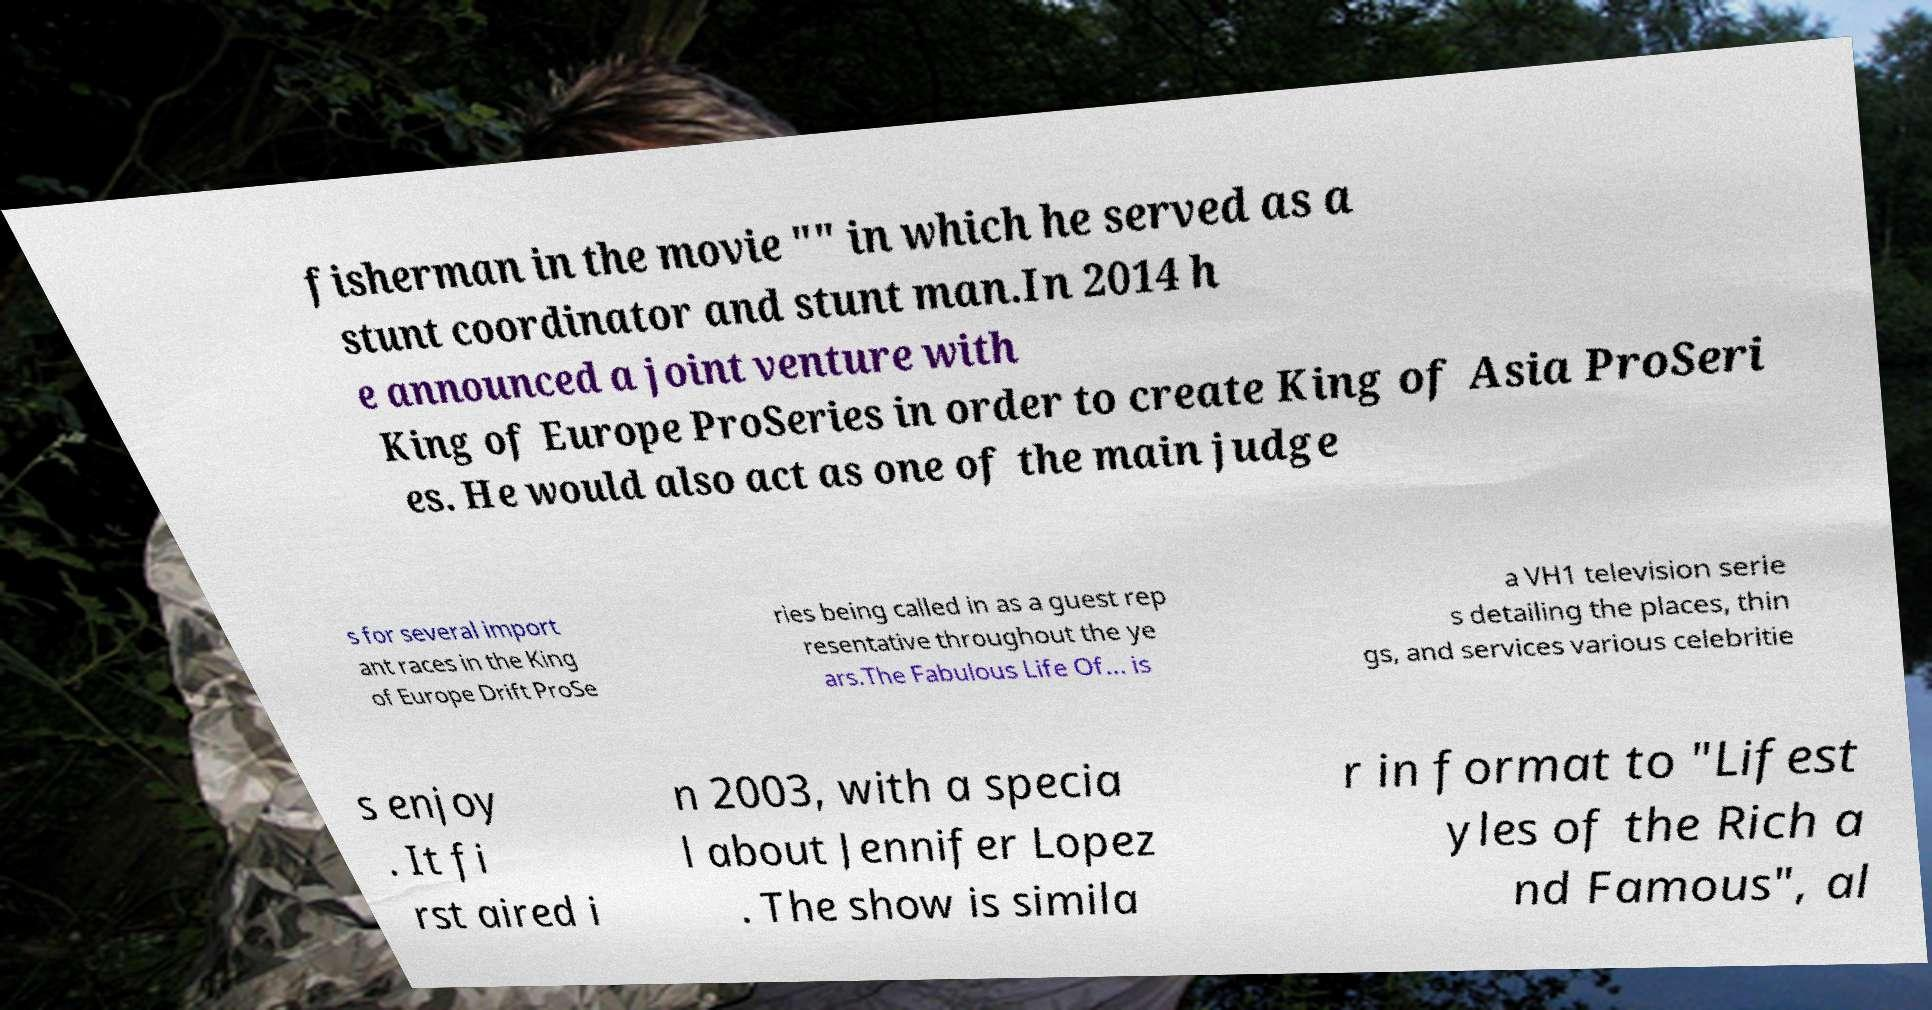Could you assist in decoding the text presented in this image and type it out clearly? fisherman in the movie "" in which he served as a stunt coordinator and stunt man.In 2014 h e announced a joint venture with King of Europe ProSeries in order to create King of Asia ProSeri es. He would also act as one of the main judge s for several import ant races in the King of Europe Drift ProSe ries being called in as a guest rep resentative throughout the ye ars.The Fabulous Life Of... is a VH1 television serie s detailing the places, thin gs, and services various celebritie s enjoy . It fi rst aired i n 2003, with a specia l about Jennifer Lopez . The show is simila r in format to "Lifest yles of the Rich a nd Famous", al 